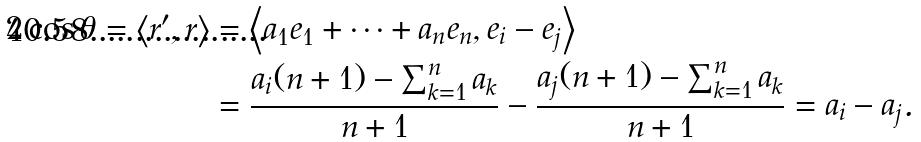<formula> <loc_0><loc_0><loc_500><loc_500>2 \cos \theta = \left \langle r ^ { \prime } , r \right \rangle & = \left \langle a _ { 1 } e _ { 1 } + \cdots + a _ { n } e _ { n } , e _ { i } - e _ { j } \right \rangle \\ & = \frac { a _ { i } ( n + 1 ) - \sum _ { k = 1 } ^ { n } a _ { k } } { n + 1 } - \frac { a _ { j } ( n + 1 ) - \sum _ { k = 1 } ^ { n } a _ { k } } { n + 1 } = a _ { i } - a _ { j } .</formula> 